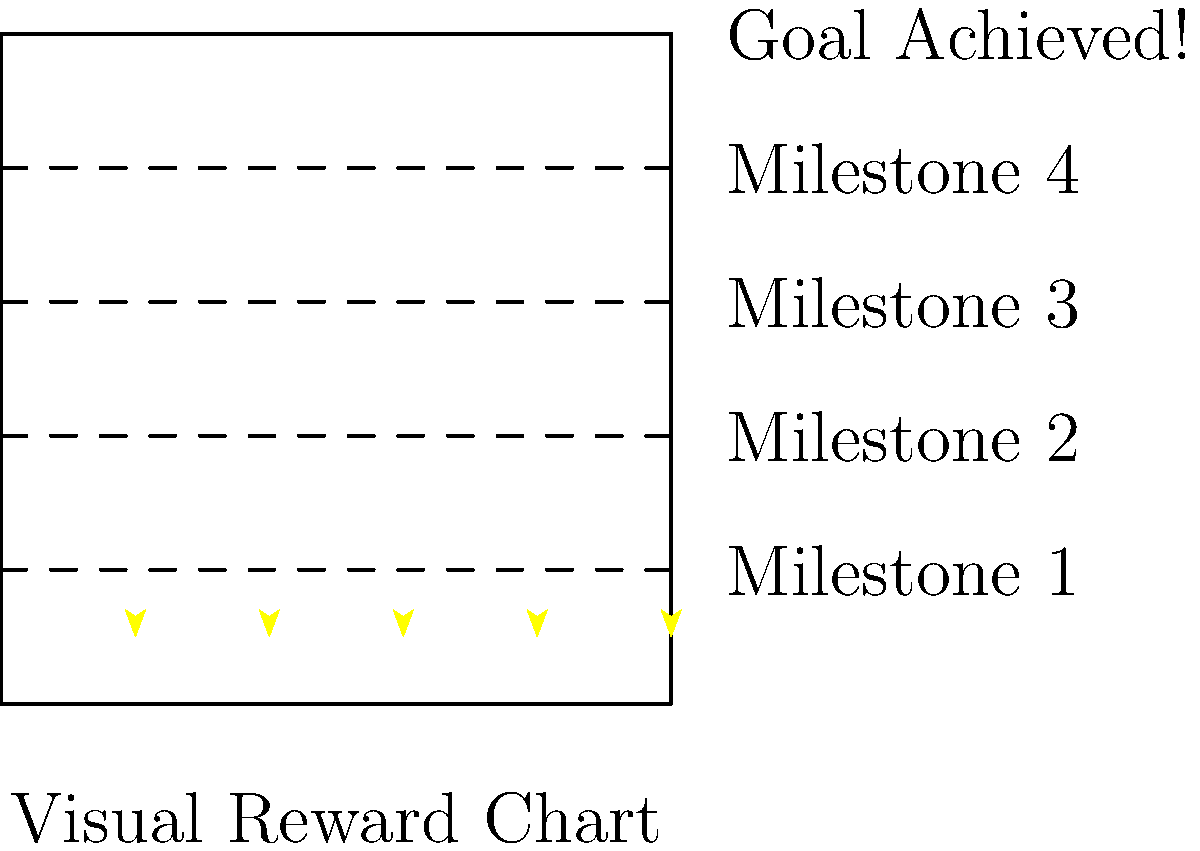In designing a visual reward chart for positive reinforcement in the classroom, how many milestone achievements should be included before reaching the final goal, according to the chart shown? To determine the number of milestone achievements in the visual reward chart, let's analyze the image step-by-step:

1. The chart is divided into horizontal sections by dashed lines.
2. Each section represents a milestone achievement.
3. Starting from the bottom, we can count the number of sections:
   - Milestone 1
   - Milestone 2
   - Milestone 3
   - Milestone 4
4. Above these milestones, there's a final section labeled "Goal Achieved!"
5. The question asks for the number of milestones before reaching the final goal.
6. We count 4 distinct milestone sections before the final "Goal Achieved!" section.

Therefore, the visual reward chart includes 4 milestone achievements before reaching the final goal.
Answer: 4 milestones 